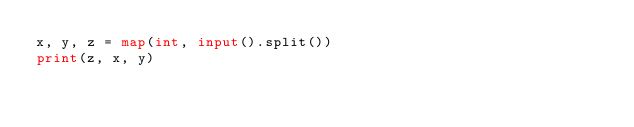<code> <loc_0><loc_0><loc_500><loc_500><_Python_>x, y, z = map(int, input().split())
print(z, x, y)
</code> 